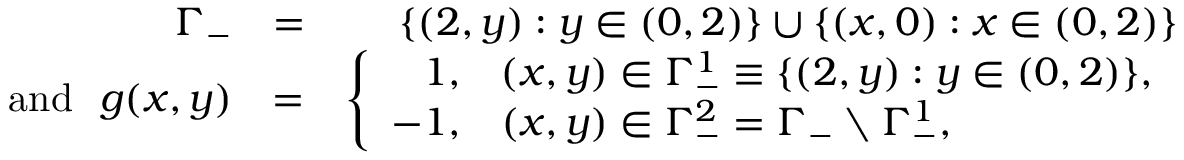Convert formula to latex. <formula><loc_0><loc_0><loc_500><loc_500>\begin{array} { r l r } { \Gamma _ { - } } & { = } & { \{ ( 2 , y ) \colon y \in ( 0 , 2 ) \} \cup \{ ( x , 0 ) \colon x \in ( 0 , 2 ) \} } \\ { a n d \, g ( x , y ) } & { = } & { \left \{ \begin{array} { r l } { 1 , } & { ( x , y ) \in \Gamma _ { - } ^ { 1 } \equiv \{ ( 2 , y ) \colon y \in ( 0 , 2 ) \} , } \\ { - 1 , } & { ( x , y ) \in \Gamma _ { - } ^ { 2 } = \Gamma _ { - } \ \Gamma _ { - } ^ { 1 } , } \end{array} } \end{array}</formula> 